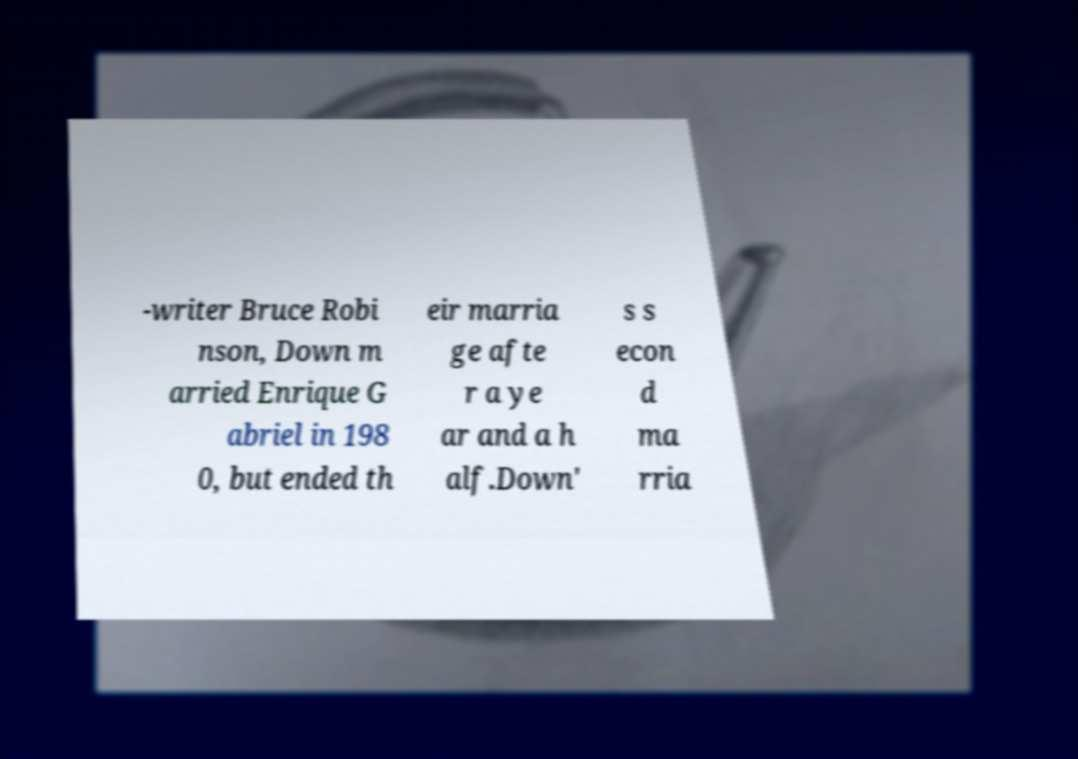For documentation purposes, I need the text within this image transcribed. Could you provide that? -writer Bruce Robi nson, Down m arried Enrique G abriel in 198 0, but ended th eir marria ge afte r a ye ar and a h alf.Down' s s econ d ma rria 